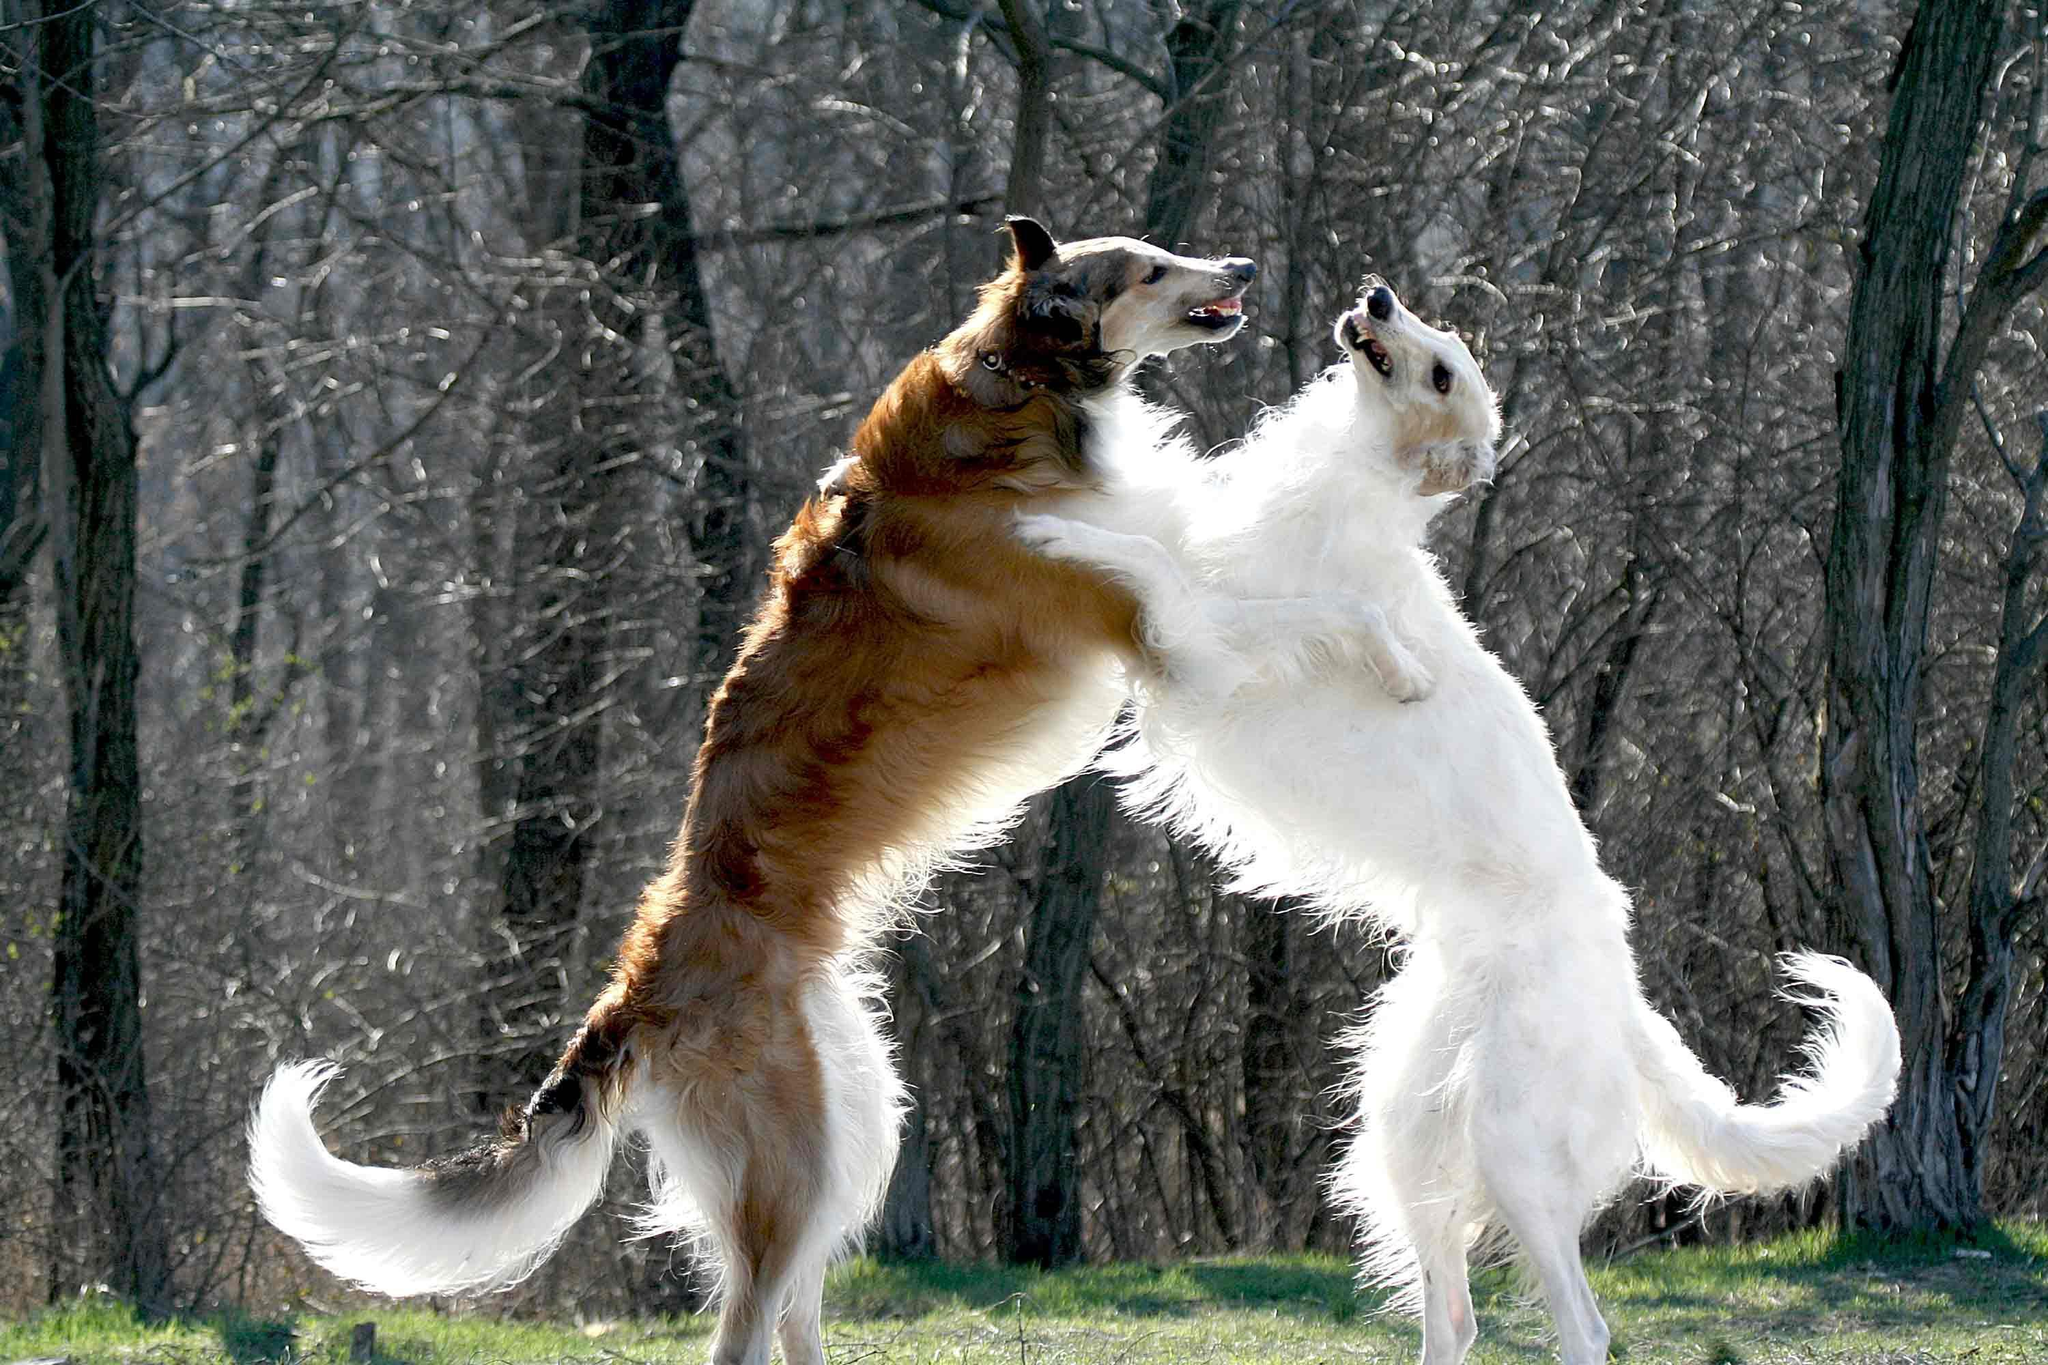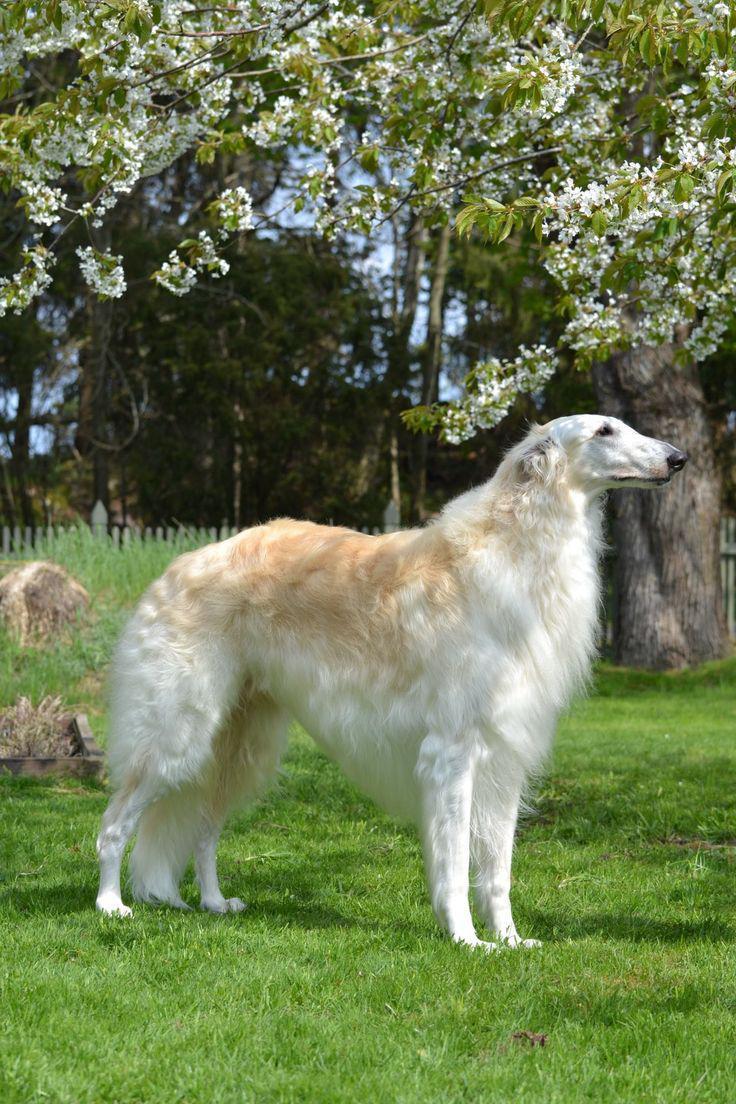The first image is the image on the left, the second image is the image on the right. For the images displayed, is the sentence "there is exactly one person in the image on the right." factually correct? Answer yes or no. No. The first image is the image on the left, the second image is the image on the right. Considering the images on both sides, is "A person is upright near a hound in one image." valid? Answer yes or no. No. 